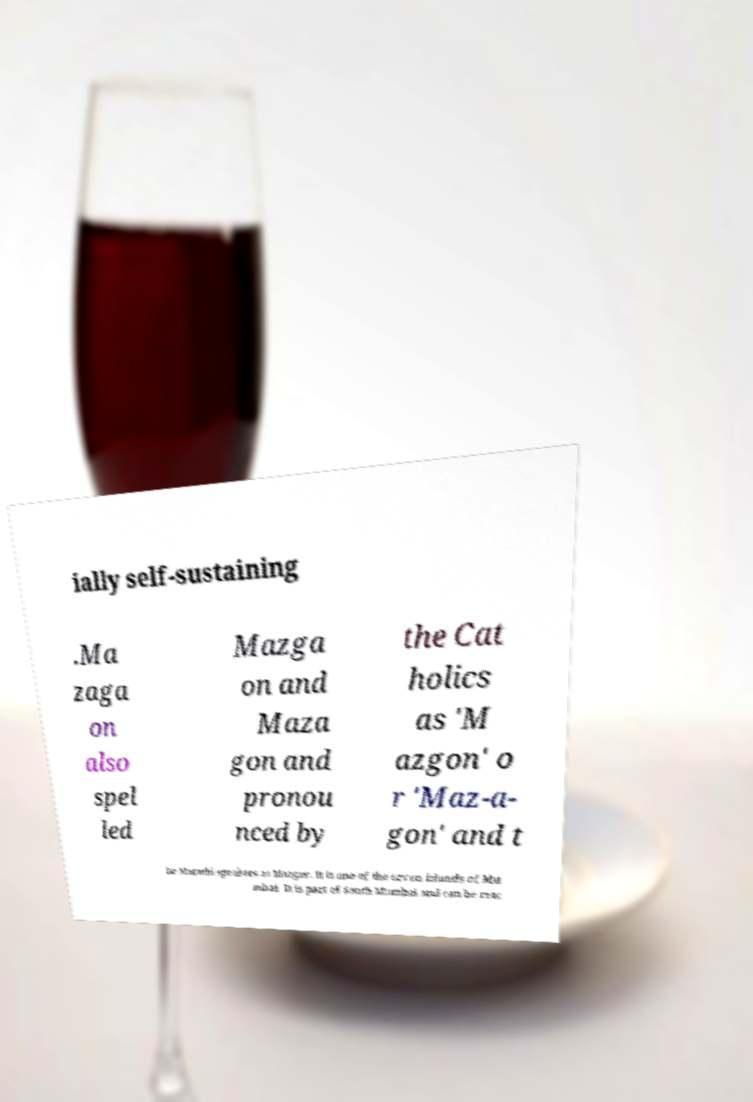Can you accurately transcribe the text from the provided image for me? ially self-sustaining .Ma zaga on also spel led Mazga on and Maza gon and pronou nced by the Cat holics as 'M azgon' o r 'Maz-a- gon' and t he Marathi-speakers as Mazgav. It is one of the seven islands of Mu mbai. It is part of South Mumbai and can be reac 